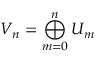Convert formula to latex. <formula><loc_0><loc_0><loc_500><loc_500>V _ { n } = \bigoplus _ { m = 0 } ^ { n } U _ { m }</formula> 